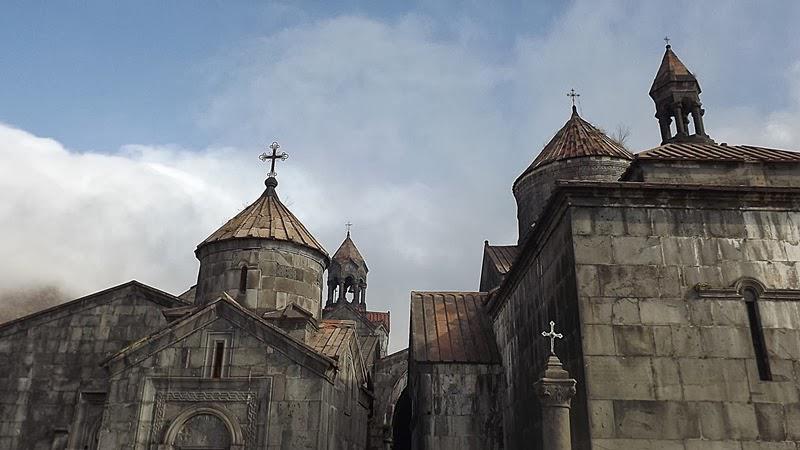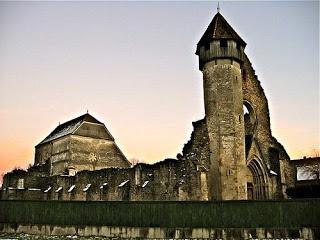The first image is the image on the left, the second image is the image on the right. Assess this claim about the two images: "There are two crosses on the building in at least one of the images.". Correct or not? Answer yes or no. Yes. 